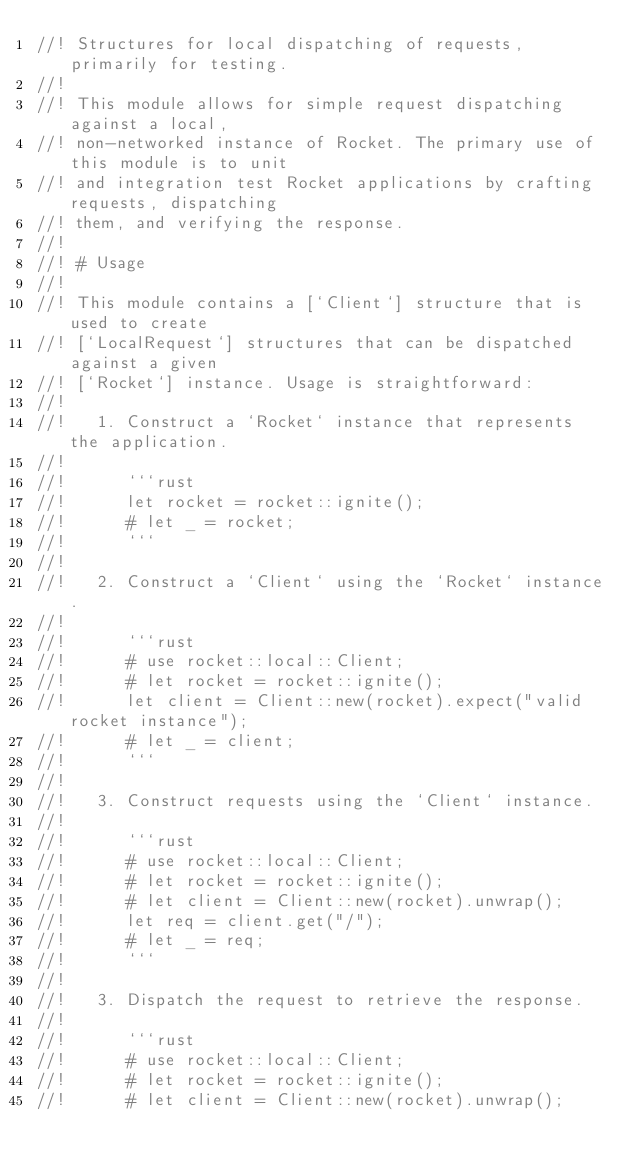Convert code to text. <code><loc_0><loc_0><loc_500><loc_500><_Rust_>//! Structures for local dispatching of requests, primarily for testing.
//!
//! This module allows for simple request dispatching against a local,
//! non-networked instance of Rocket. The primary use of this module is to unit
//! and integration test Rocket applications by crafting requests, dispatching
//! them, and verifying the response.
//!
//! # Usage
//!
//! This module contains a [`Client`] structure that is used to create
//! [`LocalRequest`] structures that can be dispatched against a given
//! [`Rocket`] instance. Usage is straightforward:
//!
//!   1. Construct a `Rocket` instance that represents the application.
//!
//!      ```rust
//!      let rocket = rocket::ignite();
//!      # let _ = rocket;
//!      ```
//!
//!   2. Construct a `Client` using the `Rocket` instance.
//!
//!      ```rust
//!      # use rocket::local::Client;
//!      # let rocket = rocket::ignite();
//!      let client = Client::new(rocket).expect("valid rocket instance");
//!      # let _ = client;
//!      ```
//!
//!   3. Construct requests using the `Client` instance.
//!
//!      ```rust
//!      # use rocket::local::Client;
//!      # let rocket = rocket::ignite();
//!      # let client = Client::new(rocket).unwrap();
//!      let req = client.get("/");
//!      # let _ = req;
//!      ```
//!
//!   3. Dispatch the request to retrieve the response.
//!
//!      ```rust
//!      # use rocket::local::Client;
//!      # let rocket = rocket::ignite();
//!      # let client = Client::new(rocket).unwrap();</code> 